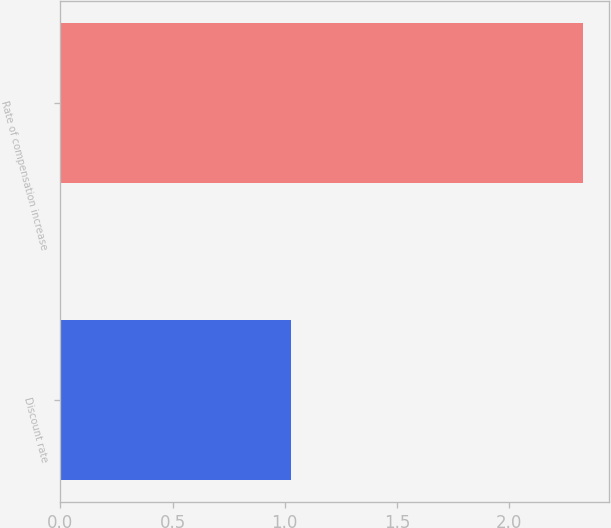<chart> <loc_0><loc_0><loc_500><loc_500><bar_chart><fcel>Discount rate<fcel>Rate of compensation increase<nl><fcel>1.03<fcel>2.33<nl></chart> 